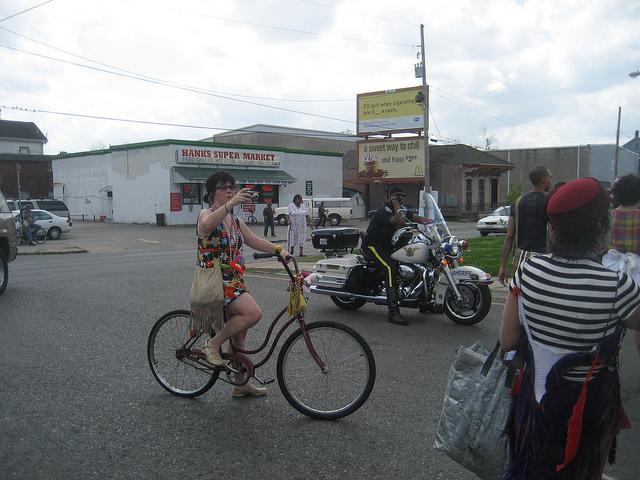How many motorcycles can be seen?
Give a very brief answer. 1. How many people are visible?
Give a very brief answer. 5. How many handbags are there?
Give a very brief answer. 2. 